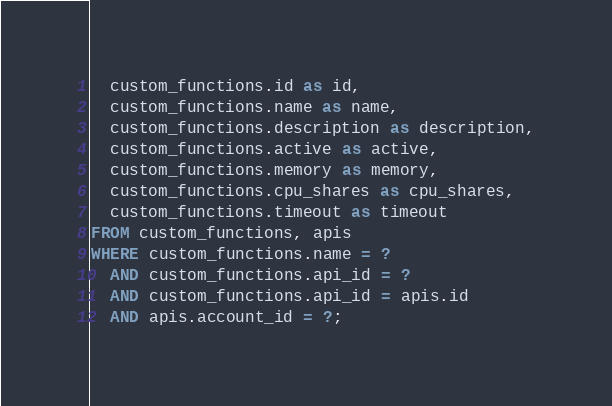<code> <loc_0><loc_0><loc_500><loc_500><_SQL_>  custom_functions.id as id,
  custom_functions.name as name,
  custom_functions.description as description,
  custom_functions.active as active,
  custom_functions.memory as memory,
  custom_functions.cpu_shares as cpu_shares,
  custom_functions.timeout as timeout
FROM custom_functions, apis
WHERE custom_functions.name = ?
  AND custom_functions.api_id = ?
  AND custom_functions.api_id = apis.id
  AND apis.account_id = ?;
</code> 